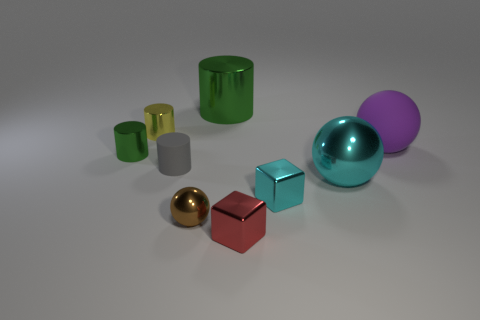Subtract all tiny cylinders. How many cylinders are left? 1 Subtract all green cylinders. How many cylinders are left? 2 Subtract all cylinders. How many objects are left? 5 Subtract 1 cylinders. How many cylinders are left? 3 Subtract all blue spheres. How many green cylinders are left? 2 Subtract all big cyan balls. Subtract all rubber objects. How many objects are left? 6 Add 7 large cylinders. How many large cylinders are left? 8 Add 6 big brown metallic cylinders. How many big brown metallic cylinders exist? 6 Subtract 0 green blocks. How many objects are left? 9 Subtract all brown cubes. Subtract all blue cylinders. How many cubes are left? 2 